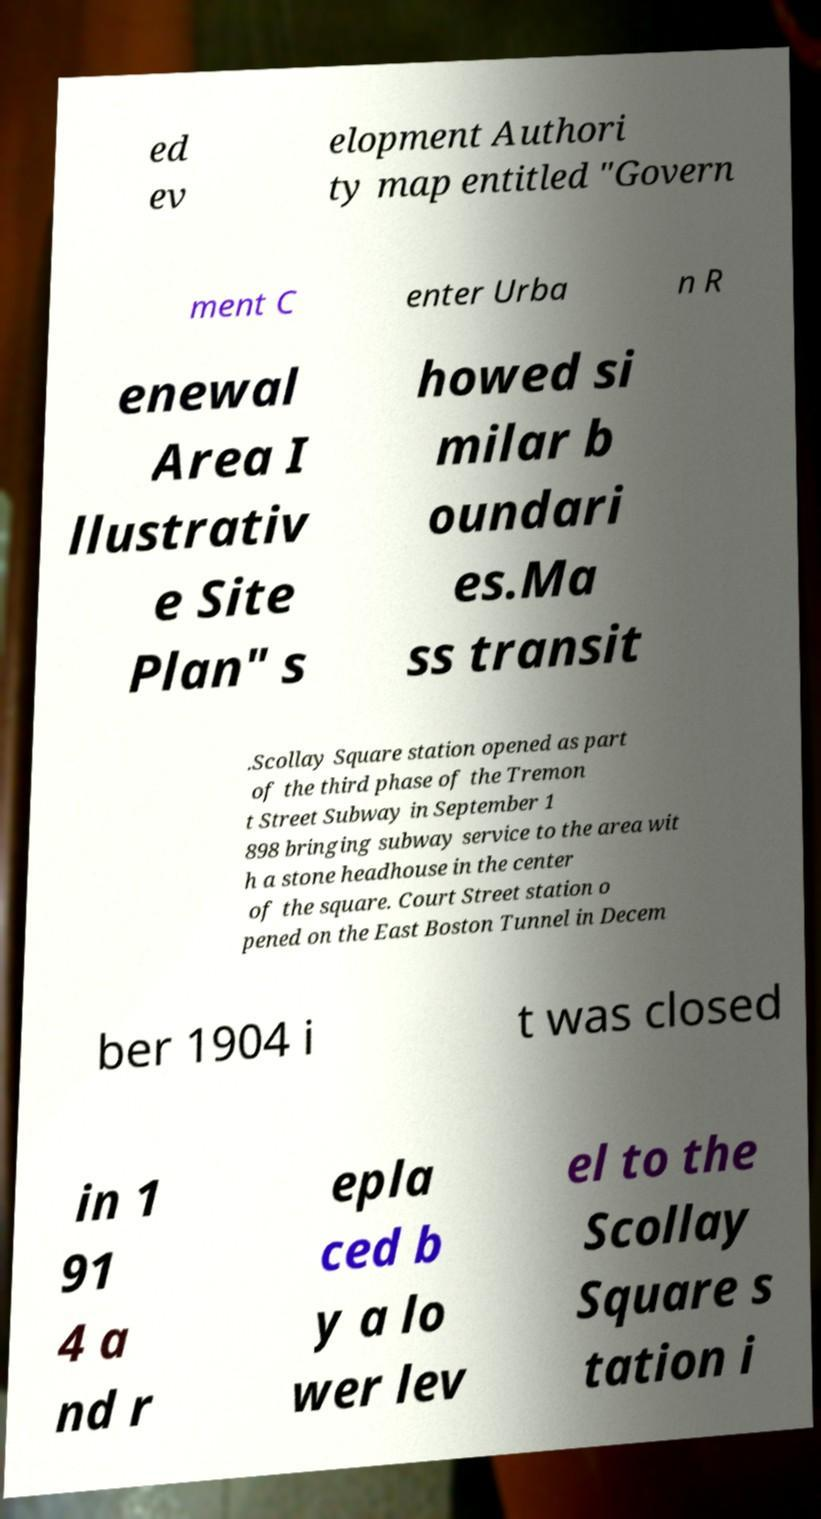There's text embedded in this image that I need extracted. Can you transcribe it verbatim? ed ev elopment Authori ty map entitled "Govern ment C enter Urba n R enewal Area I llustrativ e Site Plan" s howed si milar b oundari es.Ma ss transit .Scollay Square station opened as part of the third phase of the Tremon t Street Subway in September 1 898 bringing subway service to the area wit h a stone headhouse in the center of the square. Court Street station o pened on the East Boston Tunnel in Decem ber 1904 i t was closed in 1 91 4 a nd r epla ced b y a lo wer lev el to the Scollay Square s tation i 